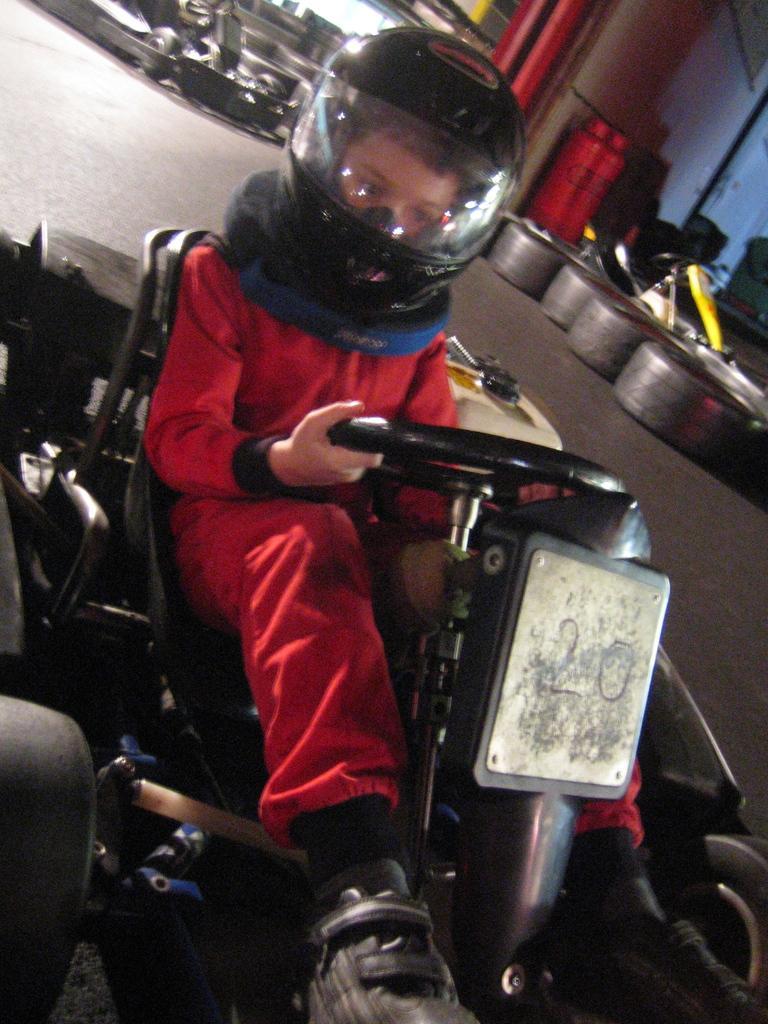Can you describe this image briefly? There is a child wearing helmet is sitting on a vehicle and holding the steering. In the back there are tires and many other things. 